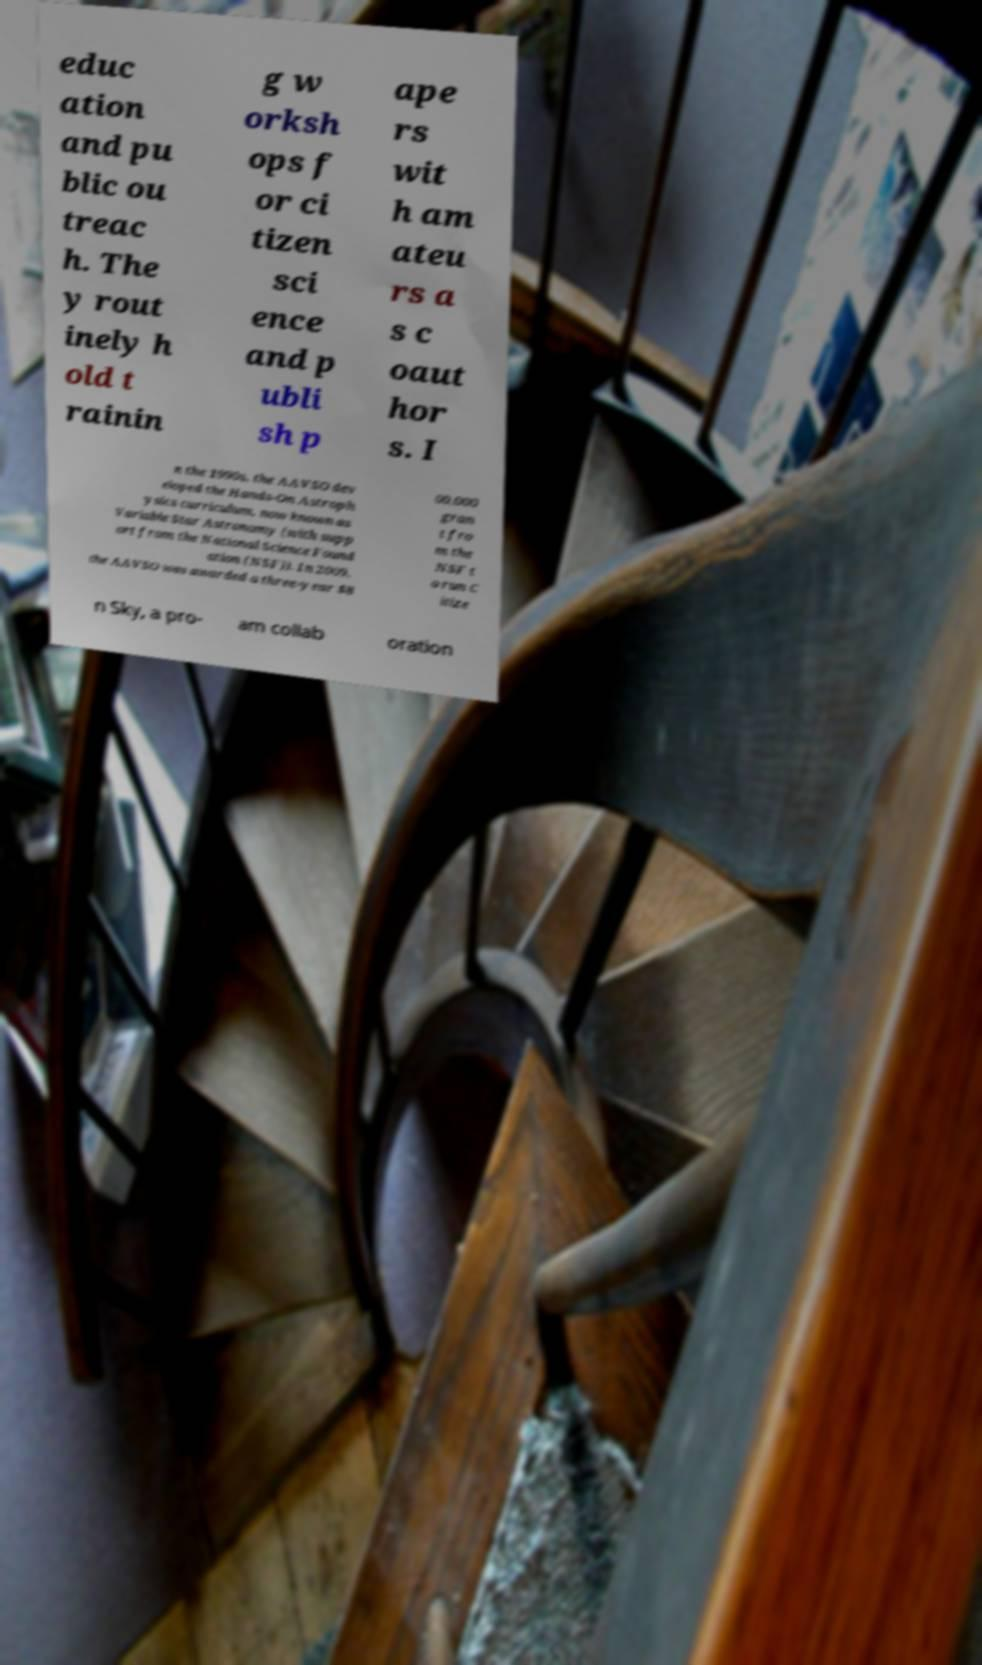I need the written content from this picture converted into text. Can you do that? educ ation and pu blic ou treac h. The y rout inely h old t rainin g w orksh ops f or ci tizen sci ence and p ubli sh p ape rs wit h am ateu rs a s c oaut hor s. I n the 1990s, the AAVSO dev eloped the Hands-On Astroph ysics curriculum, now known as Variable Star Astronomy (with supp ort from the National Science Found ation (NSF)). In 2009, the AAVSO was awarded a three-year $8 00,000 gran t fro m the NSF t o run C itize n Sky, a pro- am collab oration 